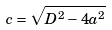Convert formula to latex. <formula><loc_0><loc_0><loc_500><loc_500>c = \sqrt { D ^ { 2 } - 4 a ^ { 2 } }</formula> 